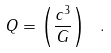<formula> <loc_0><loc_0><loc_500><loc_500>Q = \left ( \frac { c ^ { 3 } } { G } \right ) \ .</formula> 